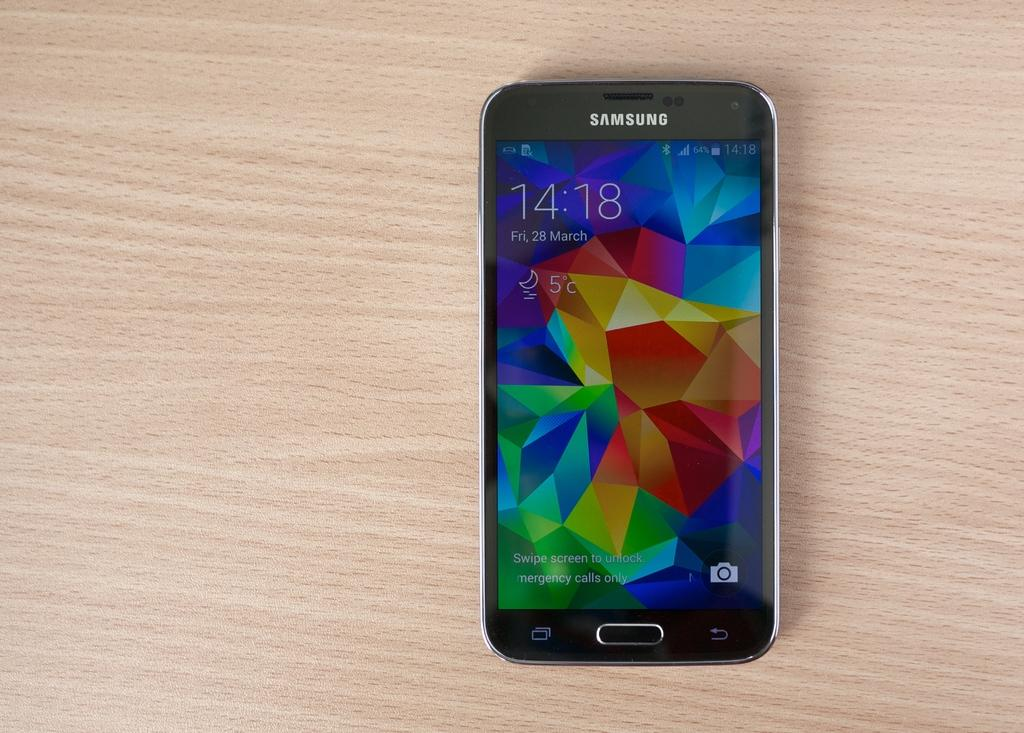<image>
Give a short and clear explanation of the subsequent image. A Samsung phone has a multicolored, geometric image on the screen. 